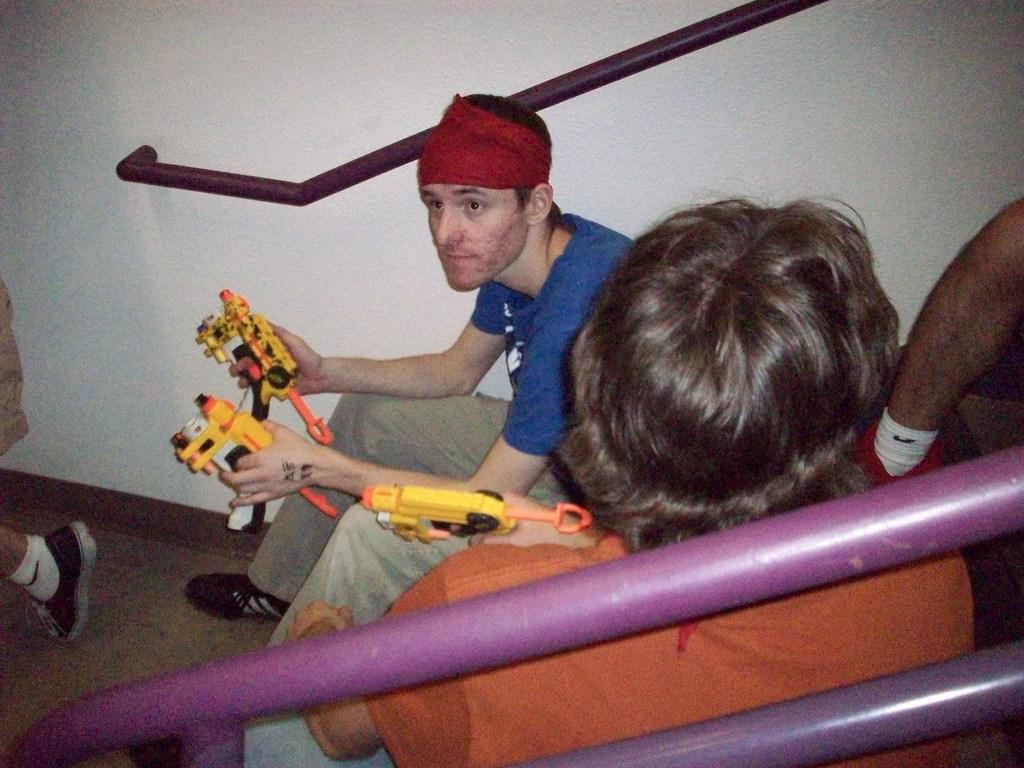How many people are in the image? There are two persons in the image. What are the persons doing in the image? The persons are sitting. What are the persons holding in their hands? The persons are holding toys in their hands. What can be seen in the background of the image? There is a wall in the background of the image. Can you tell me how many snails are crawling on the wall in the image? There are no snails visible in the image; only the two persons and the wall are present. What type of ocean can be seen in the image? There is no ocean present in the image. 